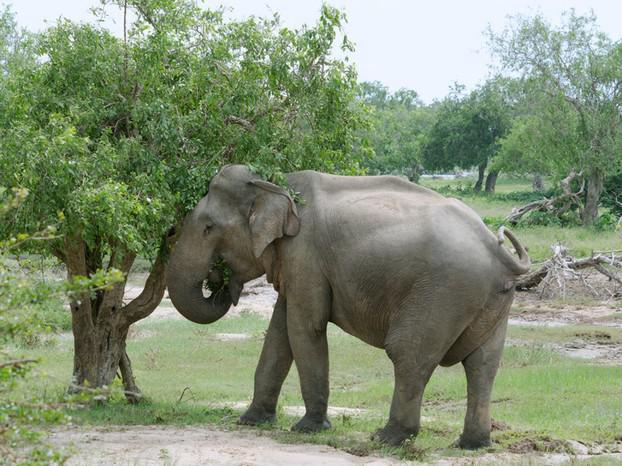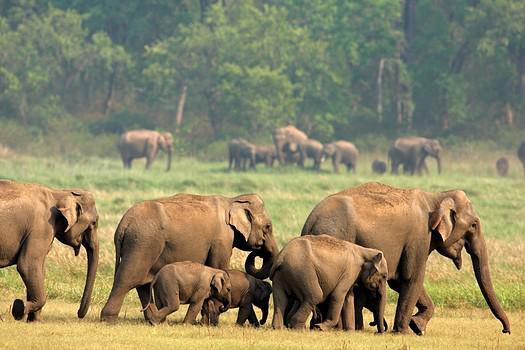The first image is the image on the left, the second image is the image on the right. Given the left and right images, does the statement "An image shows just one elephant in the foreground." hold true? Answer yes or no. Yes. 